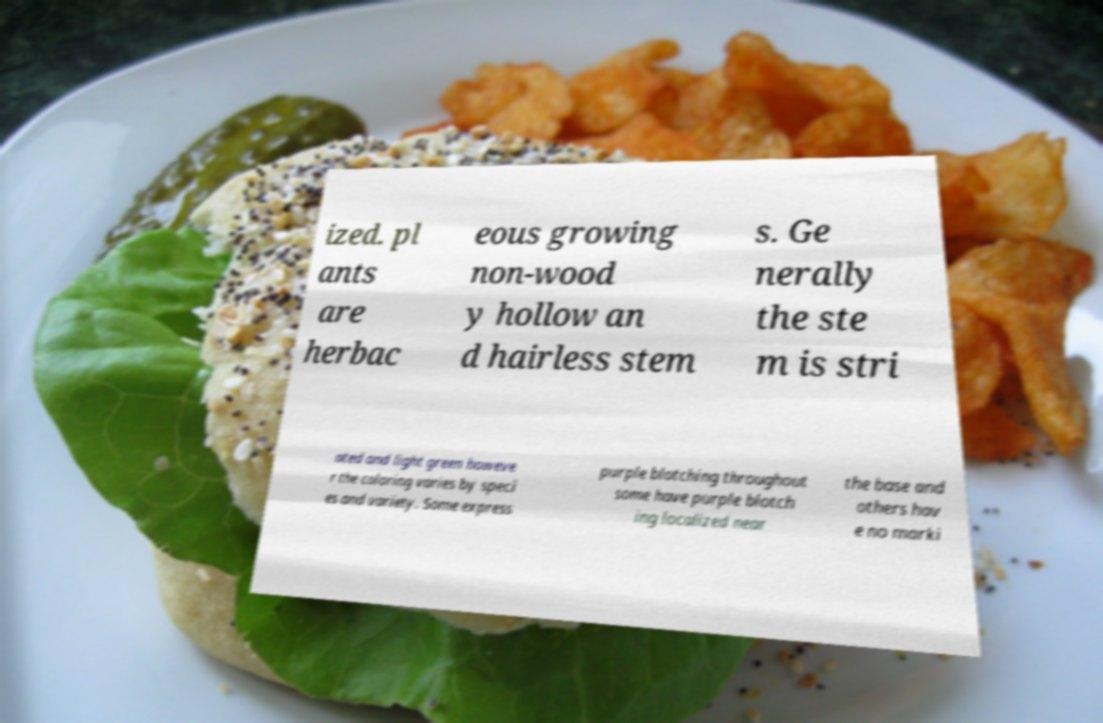Could you extract and type out the text from this image? ized. pl ants are herbac eous growing non-wood y hollow an d hairless stem s. Ge nerally the ste m is stri ated and light green howeve r the coloring varies by speci es and variety. Some express purple blotching throughout some have purple blotch ing localized near the base and others hav e no marki 